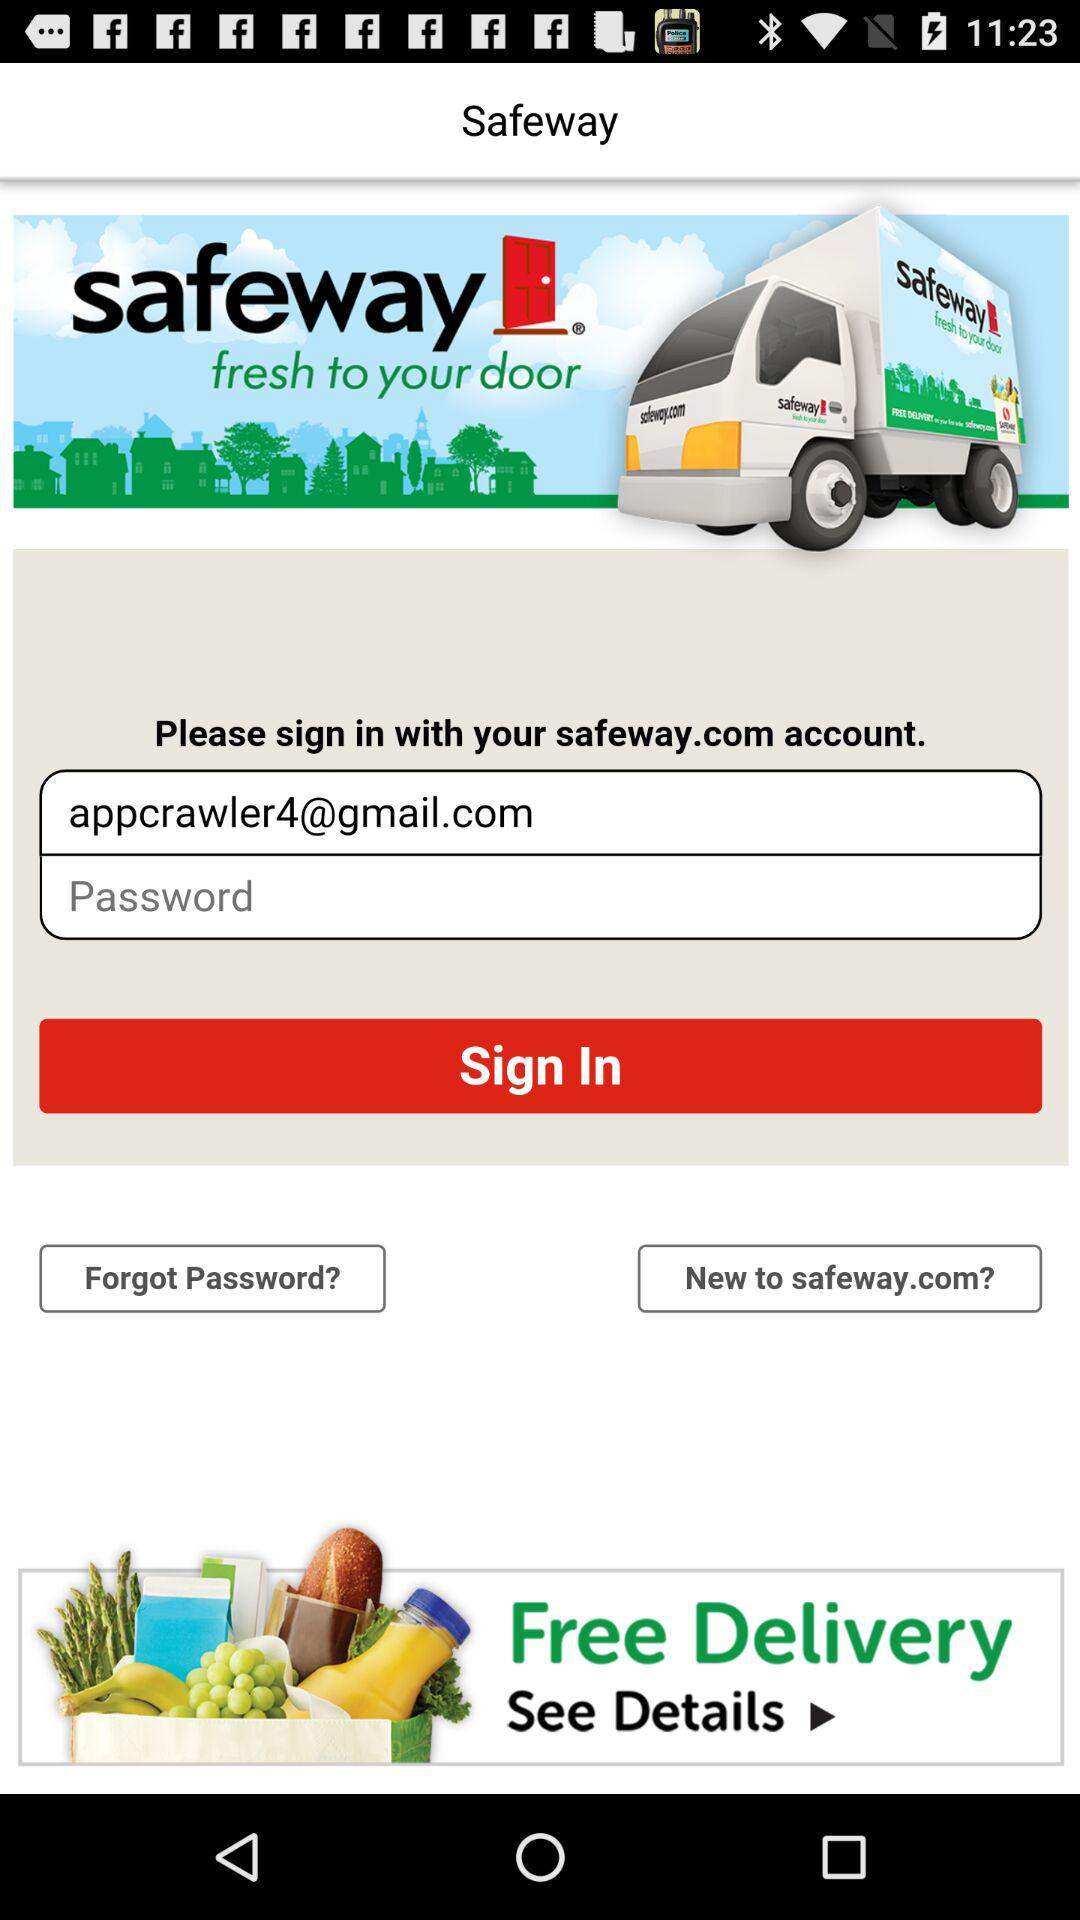How many numbers are required to create a password?
When the provided information is insufficient, respond with <no answer>. <no answer> 